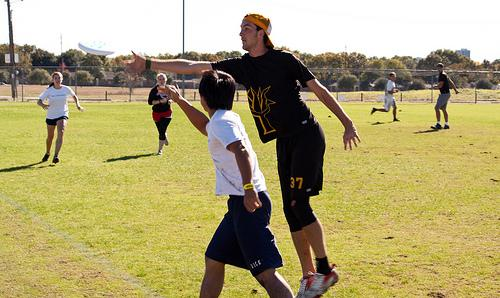Question: what are the people throwing?
Choices:
A. Football.
B. A Frisbee.
C. Baseball.
D. Potato.
Answer with the letter. Answer: B Question: what color is the man's hat?
Choices:
A. Red.
B. Orange.
C. Blue.
D. Yellow.
Answer with the letter. Answer: D Question: what are the two girls in the background doing?
Choices:
A. Riding bikes.
B. Riding horses.
C. Running.
D. Eating.
Answer with the letter. Answer: C Question: what color is the shorter boy's shirt?
Choices:
A. Black.
B. Yellow.
C. Orange.
D. White.
Answer with the letter. Answer: D Question: what number is on the boy's black shorts?
Choices:
A. Eighteen.
B. Nineteen.
C. Twenty.
D. Thirty-seven.
Answer with the letter. Answer: D 